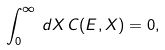<formula> <loc_0><loc_0><loc_500><loc_500>\int _ { 0 } ^ { \infty } \, d X \, C ( E , X ) = 0 ,</formula> 